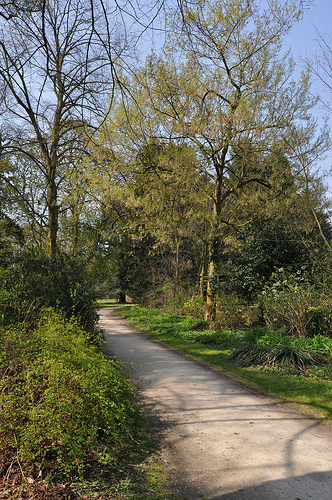<image>
Is there a tree behind the road? Yes. From this viewpoint, the tree is positioned behind the road, with the road partially or fully occluding the tree. 